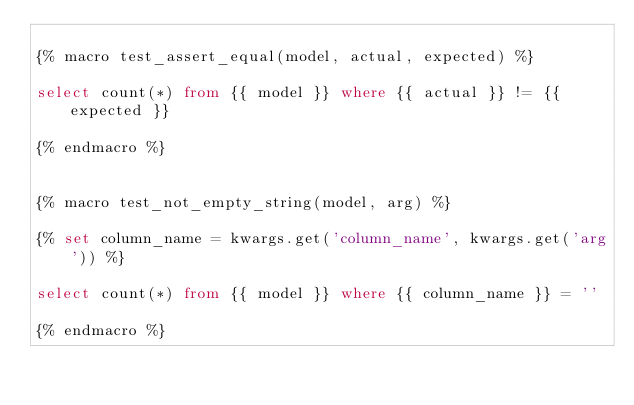Convert code to text. <code><loc_0><loc_0><loc_500><loc_500><_SQL_>
{% macro test_assert_equal(model, actual, expected) %}

select count(*) from {{ model }} where {{ actual }} != {{ expected }}

{% endmacro %}


{% macro test_not_empty_string(model, arg) %}

{% set column_name = kwargs.get('column_name', kwargs.get('arg')) %}

select count(*) from {{ model }} where {{ column_name }} = ''

{% endmacro %}
</code> 